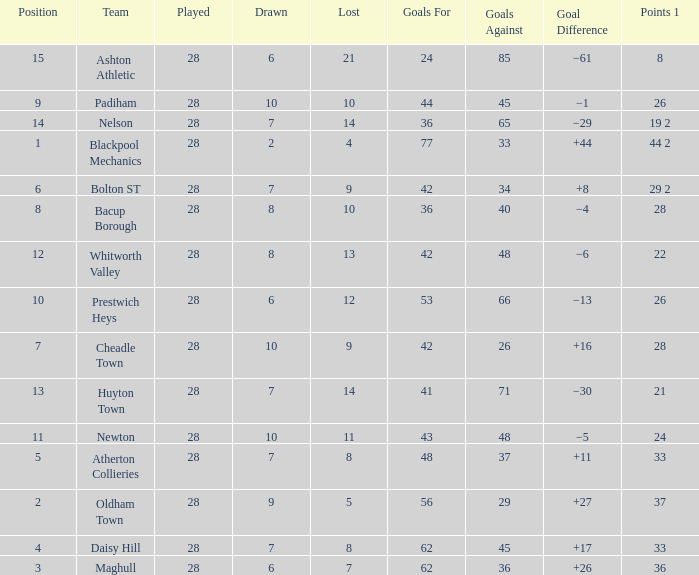What is the lowest drawn for entries with a lost of 13? 8.0. 